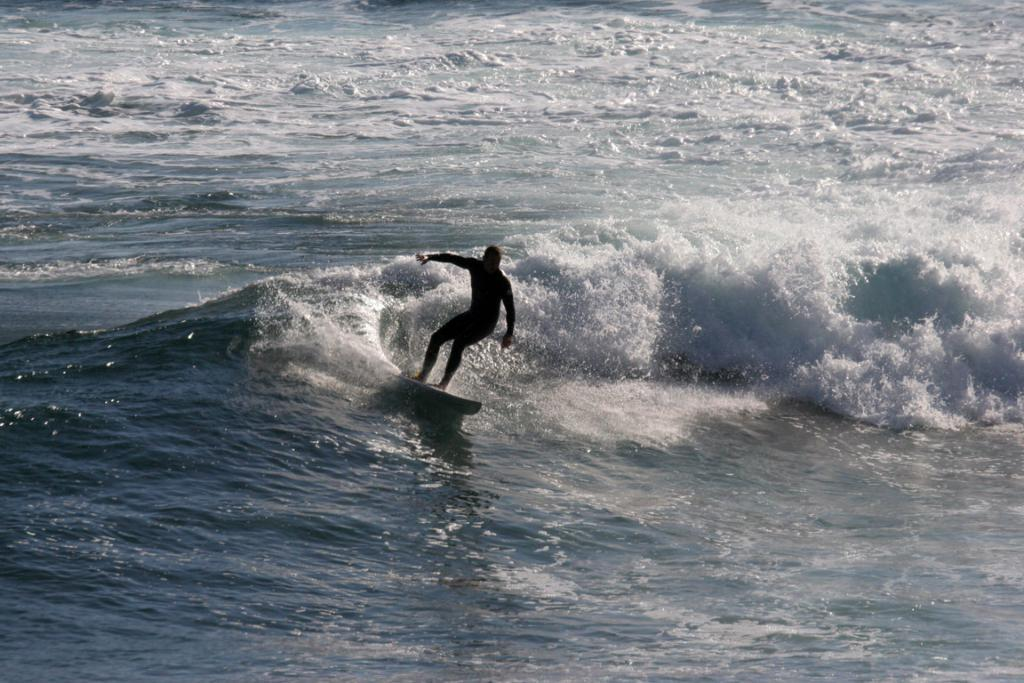What is present in the image? There is water and a person in the image. What is the person doing in the image? The person is standing on a surfing board. What type of pleasure can be seen being taken by the person in the image? There is no indication of pleasure being taken by the person in the image; they are simply standing on a surfing board. 